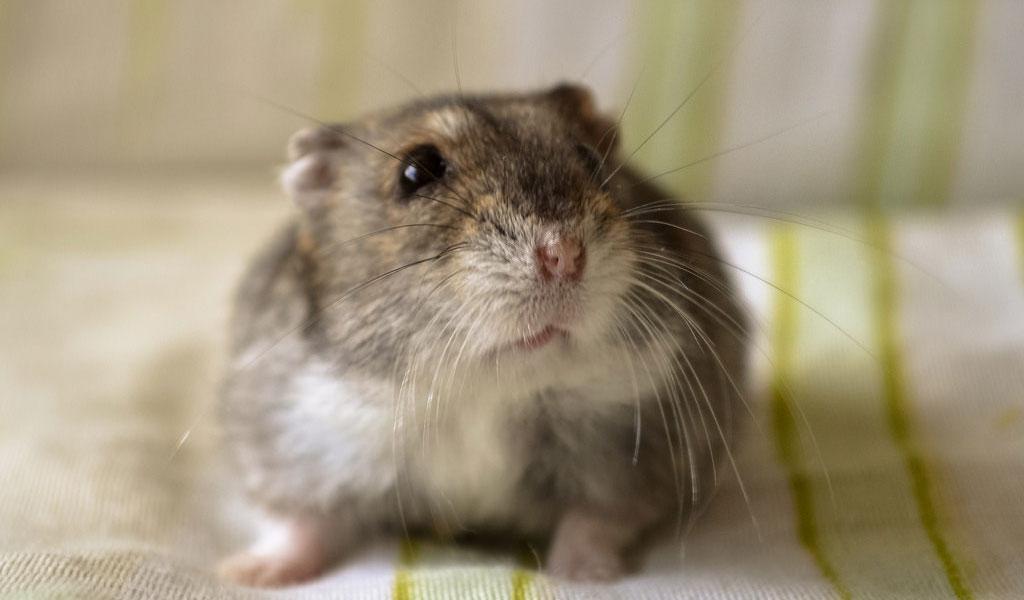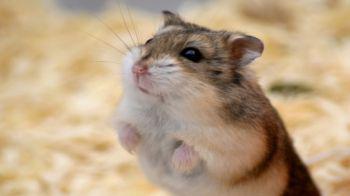The first image is the image on the left, the second image is the image on the right. Evaluate the accuracy of this statement regarding the images: "In the image to the left, there is a hamster who happens to have at least half of their fur white in color.". Is it true? Answer yes or no. No. The first image is the image on the left, the second image is the image on the right. Evaluate the accuracy of this statement regarding the images: "Each image contains one pet rodent, with one on fabric and one on shredded bedding.". Is it true? Answer yes or no. Yes. 